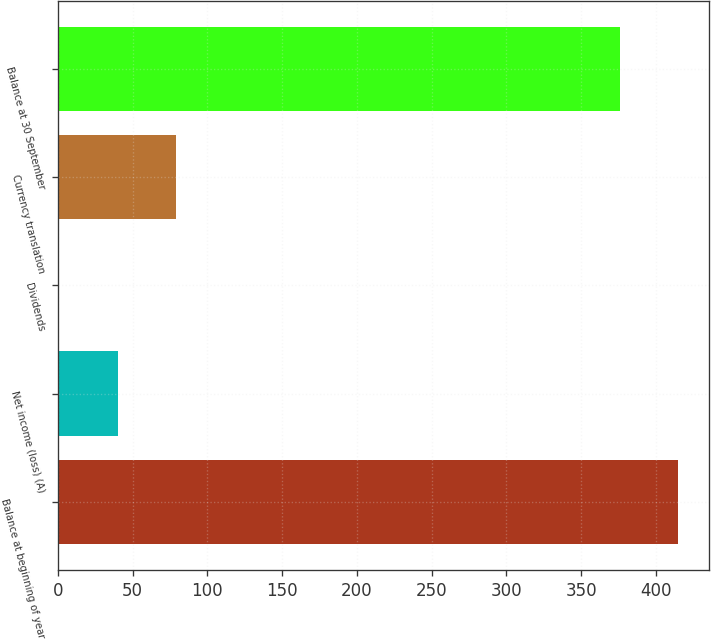Convert chart. <chart><loc_0><loc_0><loc_500><loc_500><bar_chart><fcel>Balance at beginning of year<fcel>Net income (loss) (A)<fcel>Dividends<fcel>Currency translation<fcel>Balance at 30 September<nl><fcel>414.94<fcel>40.24<fcel>1.1<fcel>79.38<fcel>375.8<nl></chart> 